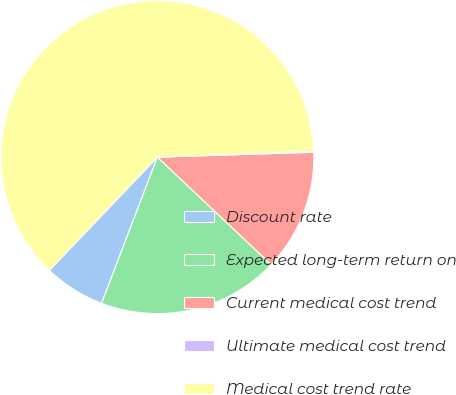<chart> <loc_0><loc_0><loc_500><loc_500><pie_chart><fcel>Discount rate<fcel>Expected long-term return on<fcel>Current medical cost trend<fcel>Ultimate medical cost trend<fcel>Medical cost trend rate<nl><fcel>6.32%<fcel>18.76%<fcel>12.54%<fcel>0.11%<fcel>62.27%<nl></chart> 